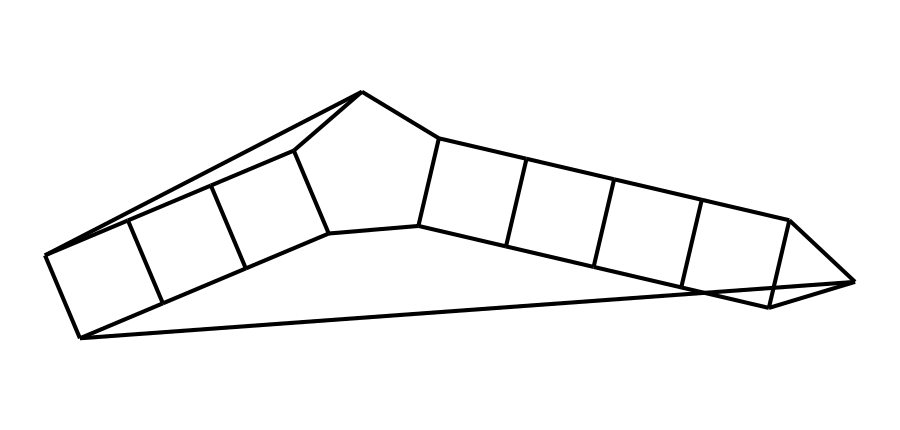how many carbon atoms are in dodecahedrane? In the structure represented by the SMILES, each "C" corresponds to a carbon atom, and counting them yields a total of 20 carbon atoms.
Answer: 20 how many hydrogen atoms are associated with dodecahedrane? For cage hydrocarbons like dodecahedrane, the formula is CnH2n, where n is the number of carbon atoms. Since there are 20 carbon atoms, the number of hydrogen atoms can be calculated as 2 times 20, equaling 40.
Answer: 40 what type of symmetry does dodecahedrane exhibit? Dodecahedrane, being a highly symmetrical cage hydrocarbon, exhibits icosahedral symmetry, characterized by its arrangement of carbon atoms and uniform distribution in three-dimensional space.
Answer: icosahedral how does the structure of dodecahedrane affect its stability? Dodecahedrane's highly symmetrical structure minimizes angle strain and steric hindrance, contributing to a lower energy state and thus enhancing its stability compared to less symmetrical structures.
Answer: enhanced stability what is the primary structural feature that defines dodecahedrane as a cage compound? The defining characteristic of dodecahedrane as a cage compound is the interconnected arrangement of carbon atoms forming a closed, three-dimensional polyhedral structure, effectively enclosing space.
Answer: interconnected structure how many vertices does the dodecahedrane structure have? Dodecahedrane mimics the structure of a dodecahedron, which has 20 vertices formed by the carbon atom connections in the cage, corresponding to its symmetrical shape.
Answer: 20 what is the significance of the unique chemical structure of dodecahedrane? The unique structure of dodecahedrane allows it to showcase the properties of large symmetrical hydrocarbons, making it important for understanding molecular geometries and potential applications in materials science.
Answer: importance in materials science 